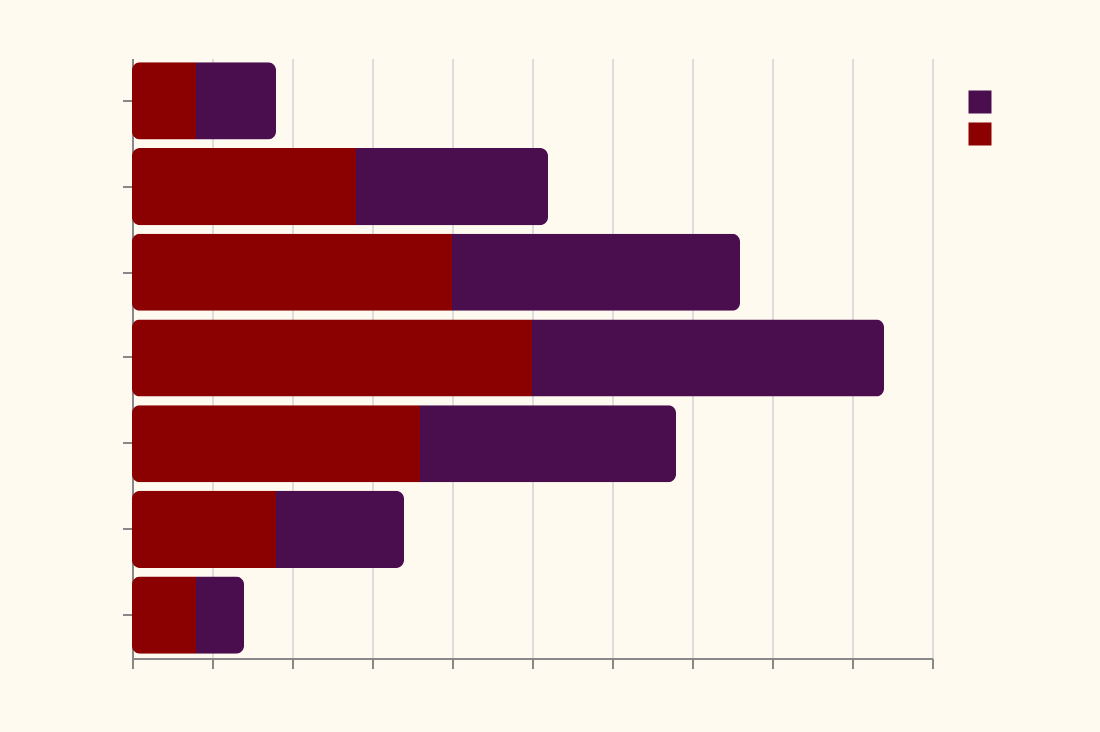What is the title of the figure? The title of the figure is prominently displayed at the top. It reads: "Haunted House Visitors by Age and Gender".
Answer: Haunted House Visitors by Age and Gender Which age group has the highest number of female visitors? The highest number of female visitors can be determined by looking at the longest bar for females, which is between 35-44 age group.
Answer: 35-44 How many male visitors are in the 25-34 age group? For the 25-34 age group, the male visitors are represented by a bar with a value of -18 (negative because male bars are on the left side).
Answer: 18 Which gender has more visitors in the 55-64 age group? We compare the lengths of the bars for men and women in the 55-64 age group. The female bar (9) is slightly longer than the male bar (-8) in the 55-64 age group.
Answer: Female What is the total number of visitors in the 0-14 age group? Add the absolute values of visitors for males (-5) and females (4) to get the total number of visitors in the 0-14 age group: 5 + 4.
Answer: 9 In which age group is the gender difference in visitors the greatest? We need to calculate the difference in the number of visitors for each age group and find the one with the greatest difference. The 35-44 age group has the maximum difference of 47 (25 - (-22)).
Answer: 35-44 Which age group has the smallest number of male visitors? Look at the smallest negative value for male visitors in all age groups. The 65+ age group has the smallest number of male visitors with a value of -3.
Answer: 65+ What is the average number of visitors for the 15-24 age group? Add the values for males and females in the 15-24 age group and then divide by 2 to get the average. The total number of visitors is 26 (-12 for males + 14 for females), so the average is 26 / 2 = 13.
Answer: 13 How does the number of female visitors in the 35-44 age group compare to the female visitors in the 0-14 age group? The number of female visitors in the 35-44 age group is 25, while the number for the 0-14 age group is 4. Thus, the 35-44 age group has significantly more female visitors.
Answer: 35-44 has significantly more female visitors 